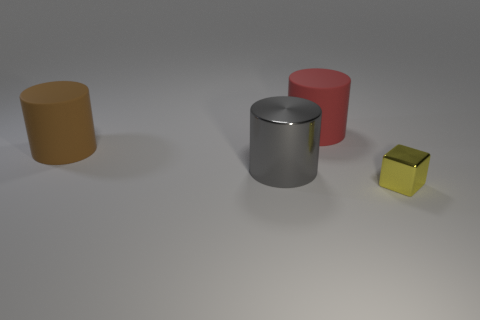Do the brown cylinder and the yellow metal thing have the same size?
Provide a short and direct response. No. How big is the shiny object in front of the metal thing that is on the left side of the red cylinder?
Your response must be concise. Small. How big is the object that is on the right side of the large gray metallic cylinder and in front of the red object?
Ensure brevity in your answer.  Small. What number of red matte things have the same size as the brown object?
Make the answer very short. 1. What number of rubber objects are small yellow objects or gray cylinders?
Give a very brief answer. 0. What material is the large cylinder in front of the large cylinder left of the big gray thing?
Your answer should be very brief. Metal. How many objects are big green rubber spheres or things left of the yellow metal object?
Make the answer very short. 3. What size is the other thing that is the same material as the gray thing?
Give a very brief answer. Small. How many brown things are either metallic cylinders or big rubber objects?
Provide a succinct answer. 1. Does the big shiny object that is right of the large brown cylinder have the same shape as the big matte thing that is on the right side of the big shiny cylinder?
Your answer should be compact. Yes. 